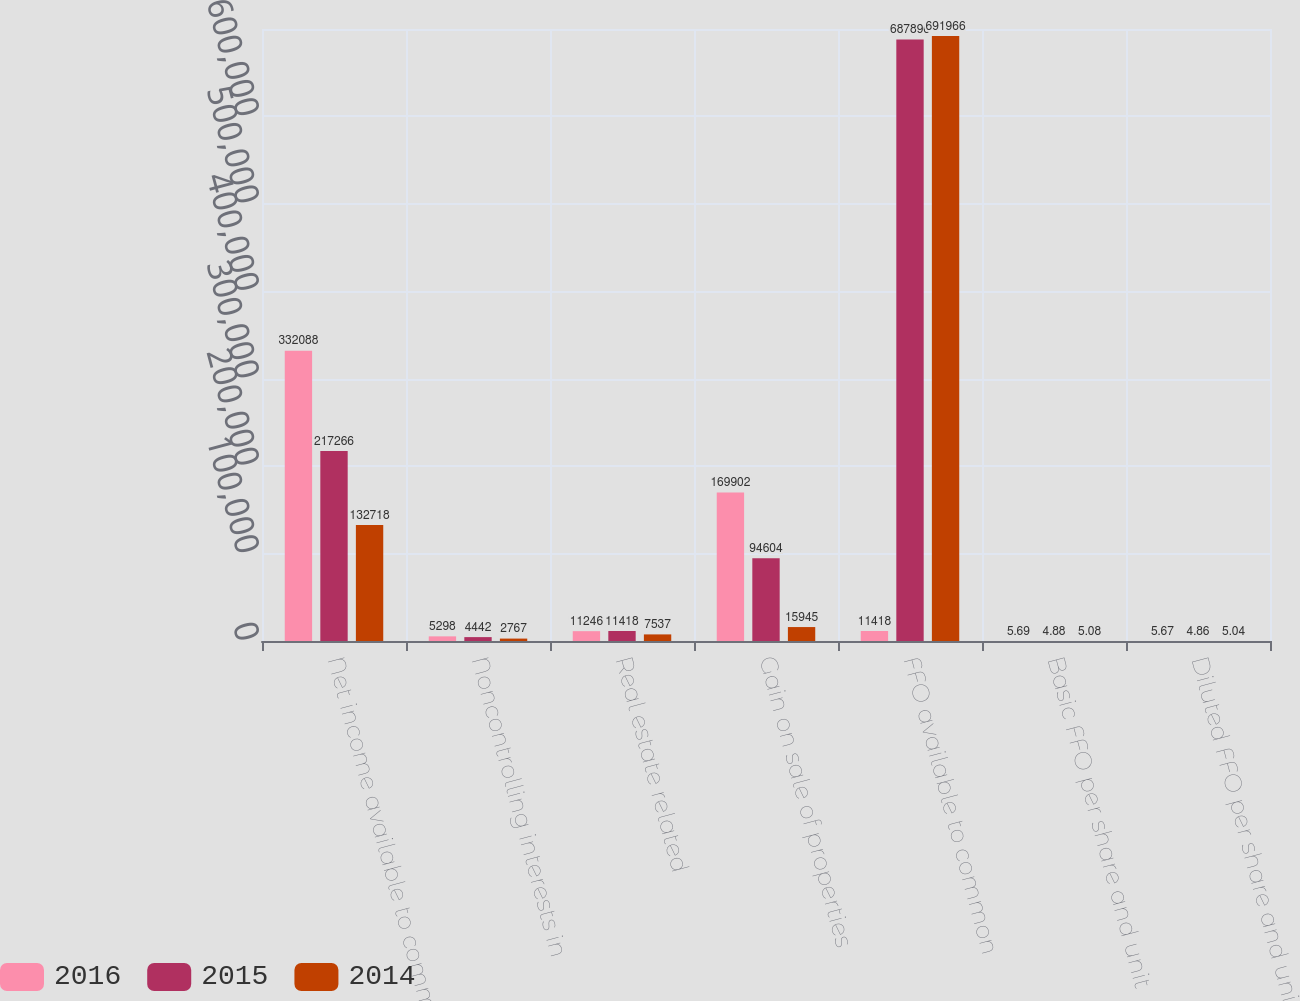Convert chart to OTSL. <chart><loc_0><loc_0><loc_500><loc_500><stacked_bar_chart><ecel><fcel>Net income available to common<fcel>Noncontrolling interests in<fcel>Real estate related<fcel>Gain on sale of properties<fcel>FFO available to common<fcel>Basic FFO per share and unit<fcel>Diluted FFO per share and unit<nl><fcel>2016<fcel>332088<fcel>5298<fcel>11246<fcel>169902<fcel>11418<fcel>5.69<fcel>5.67<nl><fcel>2015<fcel>217266<fcel>4442<fcel>11418<fcel>94604<fcel>687896<fcel>4.88<fcel>4.86<nl><fcel>2014<fcel>132718<fcel>2767<fcel>7537<fcel>15945<fcel>691966<fcel>5.08<fcel>5.04<nl></chart> 